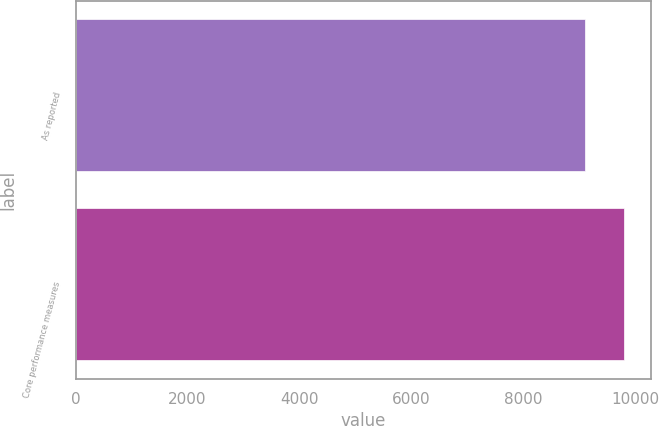Convert chart. <chart><loc_0><loc_0><loc_500><loc_500><bar_chart><fcel>As reported<fcel>Core performance measures<nl><fcel>9111<fcel>9800<nl></chart> 